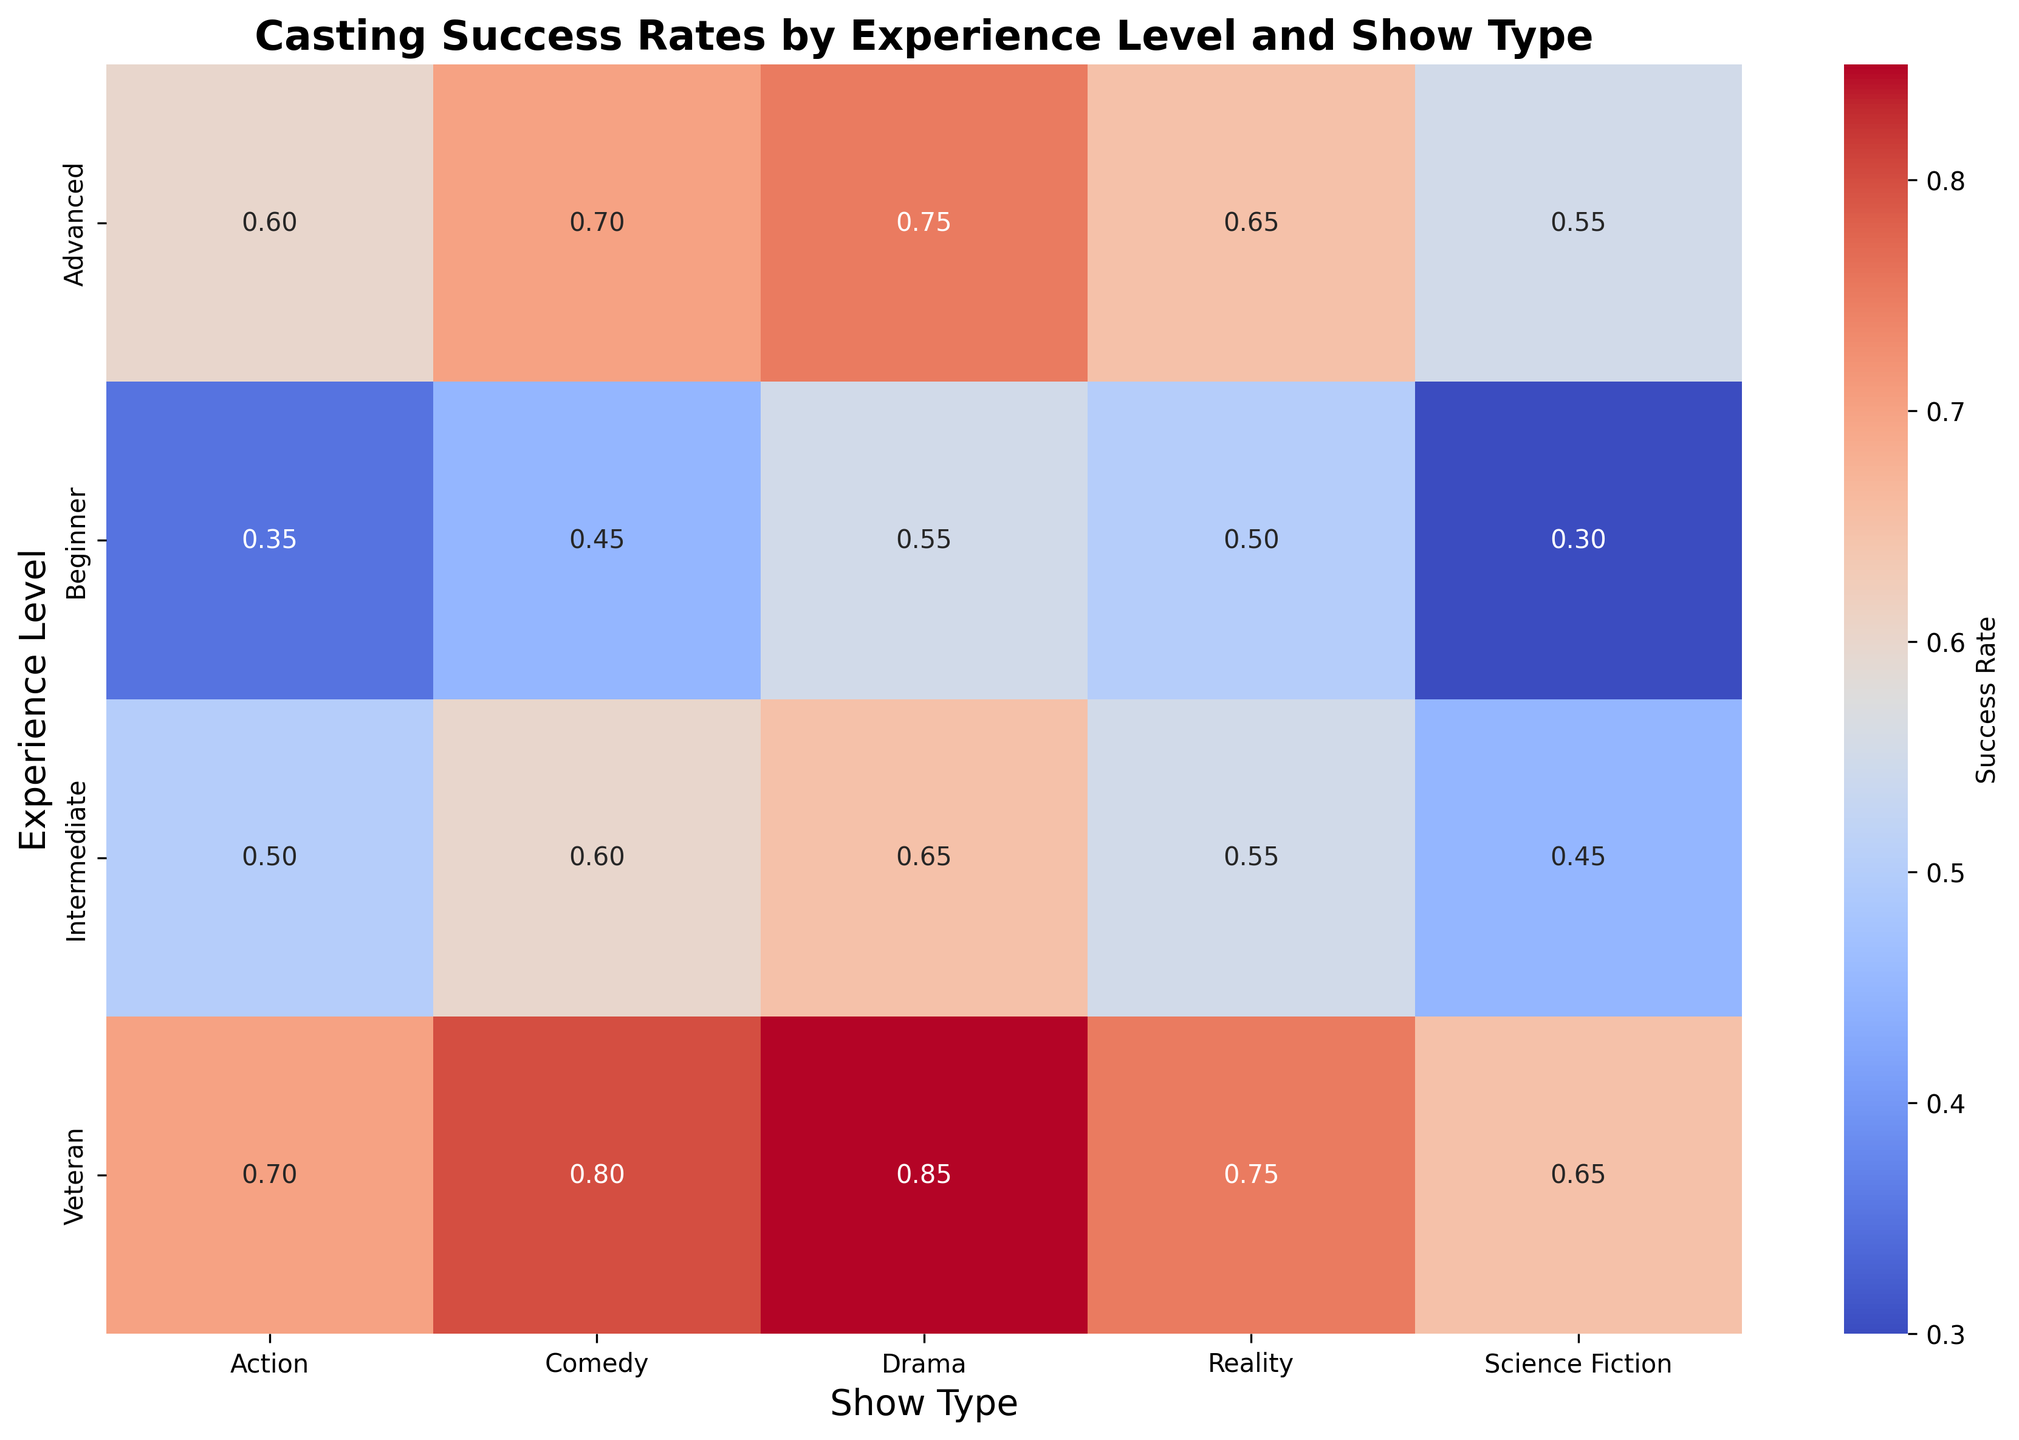Which experience level has the highest success rate in Drama shows? The heatmap shows the success rates for Drama shows across different experience levels. The darkest shade indicating the highest value appears in the "Veteran" row for the "Drama" column.
Answer: Veteran What is the average success rate for Advanced actors across all show types? To calculate the average, sum the success rates for Advanced actors across all show types (0.75, 0.70, 0.65, 0.60, 0.55) and divide by the number of show types, which is 5: (0.75 + 0.70 + 0.65 + 0.60 + 0.55) / 5 = 3.25 / 5 = 0.65
Answer: 0.65 Which show type has the least variability in success rates across all experience levels? Examine the differences in success rates for each show type across the experience levels. Comedy and Drama have larger gaps compared to Action and Science Fiction. Reality shows have uniform color shades indicating less variability.
Answer: Reality How much higher is the success rate for Veteran actors in Science Fiction shows compared to Beginner actors in the same genre? Subtract the success rate of Beginner actors in Science Fiction shows from that of Veteran actors: 0.65 - 0.30 = 0.35
Answer: 0.35 Which experience level sees the largest increase in success rate from Reality to Drama shows? Calculate the difference between the Drama and Reality success rates for each level: Beginner (0.55 - 0.50 = 0.05), Intermediate (0.65 - 0.55 = 0.10), Advanced (0.75 - 0.65 = 0.10), Veteran (0.85 - 0.75 = 0.10). The increase is largest for Intermediate, Advanced, and Veteran, but let's observe the highest numerical value
Answer: 0.10 What is the range of success rates for Intermediate actors across all show types? Identify the minimum and maximum success rates for Intermediate actors which are 0.45 (Science Fiction) and 0.65 (Drama). The range is the difference: 0.65 - 0.45 = 0.20
Answer: 0.20 In which category do experienced actors (Advanced and Veteran) have a more than 0.2 success rate difference? Calculate differences in success rates for Advanced and Veteran actors in each show category: Drama (0.85 - 0.75 = 0.10), Comedy (0.80 - 0.70 = 0.10), Reality (0.75 - 0.65 = 0.10), Action (0.70 - 0.60 = 0.10), Science Fiction (0.65 - 0.55 = 0.10); all are below 0.2
Answer: None Do Beginner actors have a higher success rate in Reality shows compared to Intermediate actors in Science Fiction shows? Compare the two success rates: Beginner actors in Reality shows (0.50) and Intermediate actors in Science Fiction shows (0.45). Since 0.50 > 0.45, Beginners in Reality shows have a higher rate.
Answer: Yes Which experience level has the smallest increase in success rate from Action to Comedy shows? Calculate the increase for each level: Beginner (0.45 - 0.35 = 0.10), Intermediate (0.60 - 0.50 = 0.10), Advanced (0.70 - 0.60 = 0.10), Veteran (0.80 - 0.70 = 0.10). The smallest increase consistently appears as 0.10 for all.
Answer: Equal By what amount does the success rate in Comedy shows increase when moving from Advanced to Veteran actors? Subtract the success rate of Advanced actors in Comedy shows from that of Veteran actors: 0.80 - 0.70 = 0.10
Answer: 0.10 